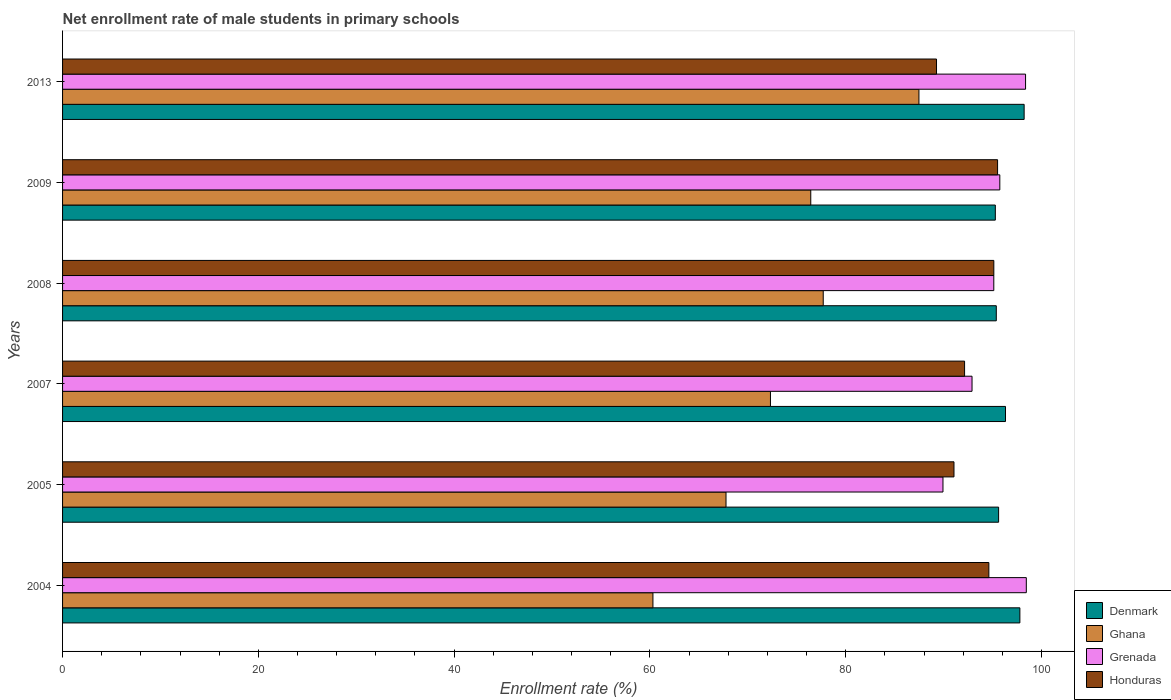How many groups of bars are there?
Make the answer very short. 6. Are the number of bars on each tick of the Y-axis equal?
Keep it short and to the point. Yes. How many bars are there on the 6th tick from the top?
Offer a terse response. 4. What is the label of the 1st group of bars from the top?
Offer a terse response. 2013. In how many cases, is the number of bars for a given year not equal to the number of legend labels?
Keep it short and to the point. 0. What is the net enrollment rate of male students in primary schools in Honduras in 2007?
Your answer should be very brief. 92.14. Across all years, what is the maximum net enrollment rate of male students in primary schools in Ghana?
Your answer should be very brief. 87.48. Across all years, what is the minimum net enrollment rate of male students in primary schools in Ghana?
Provide a short and direct response. 60.31. In which year was the net enrollment rate of male students in primary schools in Grenada maximum?
Offer a terse response. 2004. In which year was the net enrollment rate of male students in primary schools in Honduras minimum?
Your answer should be compact. 2013. What is the total net enrollment rate of male students in primary schools in Denmark in the graph?
Your response must be concise. 578.62. What is the difference between the net enrollment rate of male students in primary schools in Ghana in 2004 and that in 2005?
Offer a terse response. -7.46. What is the difference between the net enrollment rate of male students in primary schools in Denmark in 2005 and the net enrollment rate of male students in primary schools in Honduras in 2013?
Give a very brief answer. 6.34. What is the average net enrollment rate of male students in primary schools in Grenada per year?
Provide a short and direct response. 95.09. In the year 2008, what is the difference between the net enrollment rate of male students in primary schools in Grenada and net enrollment rate of male students in primary schools in Ghana?
Your answer should be very brief. 17.42. In how many years, is the net enrollment rate of male students in primary schools in Ghana greater than 88 %?
Keep it short and to the point. 0. What is the ratio of the net enrollment rate of male students in primary schools in Honduras in 2009 to that in 2013?
Ensure brevity in your answer.  1.07. Is the net enrollment rate of male students in primary schools in Grenada in 2005 less than that in 2013?
Ensure brevity in your answer.  Yes. What is the difference between the highest and the second highest net enrollment rate of male students in primary schools in Grenada?
Offer a very short reply. 0.08. What is the difference between the highest and the lowest net enrollment rate of male students in primary schools in Ghana?
Offer a very short reply. 27.17. Is the sum of the net enrollment rate of male students in primary schools in Grenada in 2005 and 2013 greater than the maximum net enrollment rate of male students in primary schools in Denmark across all years?
Your answer should be very brief. Yes. Is it the case that in every year, the sum of the net enrollment rate of male students in primary schools in Denmark and net enrollment rate of male students in primary schools in Grenada is greater than the sum of net enrollment rate of male students in primary schools in Ghana and net enrollment rate of male students in primary schools in Honduras?
Give a very brief answer. Yes. What does the 4th bar from the top in 2005 represents?
Make the answer very short. Denmark. What does the 3rd bar from the bottom in 2009 represents?
Ensure brevity in your answer.  Grenada. Is it the case that in every year, the sum of the net enrollment rate of male students in primary schools in Denmark and net enrollment rate of male students in primary schools in Honduras is greater than the net enrollment rate of male students in primary schools in Ghana?
Your response must be concise. Yes. What is the difference between two consecutive major ticks on the X-axis?
Ensure brevity in your answer.  20. Are the values on the major ticks of X-axis written in scientific E-notation?
Ensure brevity in your answer.  No. Does the graph contain any zero values?
Provide a short and direct response. No. How many legend labels are there?
Your answer should be very brief. 4. What is the title of the graph?
Provide a short and direct response. Net enrollment rate of male students in primary schools. Does "Madagascar" appear as one of the legend labels in the graph?
Your answer should be very brief. No. What is the label or title of the X-axis?
Keep it short and to the point. Enrollment rate (%). What is the label or title of the Y-axis?
Give a very brief answer. Years. What is the Enrollment rate (%) in Denmark in 2004?
Offer a terse response. 97.79. What is the Enrollment rate (%) in Ghana in 2004?
Offer a terse response. 60.31. What is the Enrollment rate (%) in Grenada in 2004?
Offer a terse response. 98.45. What is the Enrollment rate (%) of Honduras in 2004?
Offer a terse response. 94.62. What is the Enrollment rate (%) of Denmark in 2005?
Provide a short and direct response. 95.62. What is the Enrollment rate (%) in Ghana in 2005?
Make the answer very short. 67.77. What is the Enrollment rate (%) in Grenada in 2005?
Give a very brief answer. 89.93. What is the Enrollment rate (%) in Honduras in 2005?
Offer a very short reply. 91.06. What is the Enrollment rate (%) in Denmark in 2007?
Offer a very short reply. 96.32. What is the Enrollment rate (%) in Ghana in 2007?
Your answer should be very brief. 72.31. What is the Enrollment rate (%) of Grenada in 2007?
Your answer should be compact. 92.9. What is the Enrollment rate (%) in Honduras in 2007?
Your answer should be very brief. 92.14. What is the Enrollment rate (%) in Denmark in 2008?
Make the answer very short. 95.38. What is the Enrollment rate (%) of Ghana in 2008?
Keep it short and to the point. 77.7. What is the Enrollment rate (%) in Grenada in 2008?
Provide a succinct answer. 95.13. What is the Enrollment rate (%) of Honduras in 2008?
Keep it short and to the point. 95.13. What is the Enrollment rate (%) in Denmark in 2009?
Offer a terse response. 95.28. What is the Enrollment rate (%) of Ghana in 2009?
Offer a very short reply. 76.43. What is the Enrollment rate (%) in Grenada in 2009?
Ensure brevity in your answer.  95.74. What is the Enrollment rate (%) of Honduras in 2009?
Offer a very short reply. 95.51. What is the Enrollment rate (%) of Denmark in 2013?
Your answer should be very brief. 98.23. What is the Enrollment rate (%) of Ghana in 2013?
Offer a very short reply. 87.48. What is the Enrollment rate (%) in Grenada in 2013?
Your response must be concise. 98.37. What is the Enrollment rate (%) of Honduras in 2013?
Offer a very short reply. 89.28. Across all years, what is the maximum Enrollment rate (%) in Denmark?
Your answer should be compact. 98.23. Across all years, what is the maximum Enrollment rate (%) of Ghana?
Make the answer very short. 87.48. Across all years, what is the maximum Enrollment rate (%) of Grenada?
Offer a terse response. 98.45. Across all years, what is the maximum Enrollment rate (%) in Honduras?
Your answer should be compact. 95.51. Across all years, what is the minimum Enrollment rate (%) of Denmark?
Provide a short and direct response. 95.28. Across all years, what is the minimum Enrollment rate (%) of Ghana?
Ensure brevity in your answer.  60.31. Across all years, what is the minimum Enrollment rate (%) of Grenada?
Keep it short and to the point. 89.93. Across all years, what is the minimum Enrollment rate (%) of Honduras?
Ensure brevity in your answer.  89.28. What is the total Enrollment rate (%) in Denmark in the graph?
Your answer should be very brief. 578.62. What is the total Enrollment rate (%) of Ghana in the graph?
Give a very brief answer. 442. What is the total Enrollment rate (%) in Grenada in the graph?
Give a very brief answer. 570.52. What is the total Enrollment rate (%) in Honduras in the graph?
Offer a very short reply. 557.74. What is the difference between the Enrollment rate (%) in Denmark in 2004 and that in 2005?
Your response must be concise. 2.17. What is the difference between the Enrollment rate (%) of Ghana in 2004 and that in 2005?
Your answer should be very brief. -7.46. What is the difference between the Enrollment rate (%) of Grenada in 2004 and that in 2005?
Offer a very short reply. 8.51. What is the difference between the Enrollment rate (%) of Honduras in 2004 and that in 2005?
Your answer should be very brief. 3.56. What is the difference between the Enrollment rate (%) in Denmark in 2004 and that in 2007?
Keep it short and to the point. 1.47. What is the difference between the Enrollment rate (%) of Ghana in 2004 and that in 2007?
Make the answer very short. -12. What is the difference between the Enrollment rate (%) in Grenada in 2004 and that in 2007?
Give a very brief answer. 5.54. What is the difference between the Enrollment rate (%) in Honduras in 2004 and that in 2007?
Your answer should be compact. 2.48. What is the difference between the Enrollment rate (%) of Denmark in 2004 and that in 2008?
Make the answer very short. 2.41. What is the difference between the Enrollment rate (%) in Ghana in 2004 and that in 2008?
Make the answer very short. -17.4. What is the difference between the Enrollment rate (%) in Grenada in 2004 and that in 2008?
Your response must be concise. 3.32. What is the difference between the Enrollment rate (%) in Honduras in 2004 and that in 2008?
Provide a succinct answer. -0.51. What is the difference between the Enrollment rate (%) of Denmark in 2004 and that in 2009?
Offer a very short reply. 2.51. What is the difference between the Enrollment rate (%) in Ghana in 2004 and that in 2009?
Give a very brief answer. -16.12. What is the difference between the Enrollment rate (%) in Grenada in 2004 and that in 2009?
Provide a short and direct response. 2.71. What is the difference between the Enrollment rate (%) in Honduras in 2004 and that in 2009?
Keep it short and to the point. -0.89. What is the difference between the Enrollment rate (%) in Denmark in 2004 and that in 2013?
Ensure brevity in your answer.  -0.44. What is the difference between the Enrollment rate (%) of Ghana in 2004 and that in 2013?
Offer a very short reply. -27.17. What is the difference between the Enrollment rate (%) in Grenada in 2004 and that in 2013?
Offer a very short reply. 0.08. What is the difference between the Enrollment rate (%) in Honduras in 2004 and that in 2013?
Your response must be concise. 5.35. What is the difference between the Enrollment rate (%) in Denmark in 2005 and that in 2007?
Provide a short and direct response. -0.7. What is the difference between the Enrollment rate (%) of Ghana in 2005 and that in 2007?
Offer a very short reply. -4.54. What is the difference between the Enrollment rate (%) of Grenada in 2005 and that in 2007?
Your response must be concise. -2.97. What is the difference between the Enrollment rate (%) in Honduras in 2005 and that in 2007?
Your answer should be very brief. -1.08. What is the difference between the Enrollment rate (%) in Denmark in 2005 and that in 2008?
Make the answer very short. 0.24. What is the difference between the Enrollment rate (%) of Ghana in 2005 and that in 2008?
Your response must be concise. -9.93. What is the difference between the Enrollment rate (%) in Grenada in 2005 and that in 2008?
Offer a very short reply. -5.19. What is the difference between the Enrollment rate (%) of Honduras in 2005 and that in 2008?
Provide a succinct answer. -4.07. What is the difference between the Enrollment rate (%) in Denmark in 2005 and that in 2009?
Your response must be concise. 0.33. What is the difference between the Enrollment rate (%) in Ghana in 2005 and that in 2009?
Your answer should be compact. -8.66. What is the difference between the Enrollment rate (%) of Grenada in 2005 and that in 2009?
Provide a succinct answer. -5.81. What is the difference between the Enrollment rate (%) of Honduras in 2005 and that in 2009?
Your answer should be very brief. -4.45. What is the difference between the Enrollment rate (%) in Denmark in 2005 and that in 2013?
Offer a terse response. -2.61. What is the difference between the Enrollment rate (%) of Ghana in 2005 and that in 2013?
Provide a short and direct response. -19.71. What is the difference between the Enrollment rate (%) in Grenada in 2005 and that in 2013?
Offer a very short reply. -8.44. What is the difference between the Enrollment rate (%) in Honduras in 2005 and that in 2013?
Keep it short and to the point. 1.78. What is the difference between the Enrollment rate (%) in Denmark in 2007 and that in 2008?
Your answer should be very brief. 0.94. What is the difference between the Enrollment rate (%) of Ghana in 2007 and that in 2008?
Offer a very short reply. -5.39. What is the difference between the Enrollment rate (%) of Grenada in 2007 and that in 2008?
Give a very brief answer. -2.22. What is the difference between the Enrollment rate (%) in Honduras in 2007 and that in 2008?
Provide a short and direct response. -2.99. What is the difference between the Enrollment rate (%) of Denmark in 2007 and that in 2009?
Make the answer very short. 1.04. What is the difference between the Enrollment rate (%) in Ghana in 2007 and that in 2009?
Keep it short and to the point. -4.12. What is the difference between the Enrollment rate (%) in Grenada in 2007 and that in 2009?
Make the answer very short. -2.84. What is the difference between the Enrollment rate (%) in Honduras in 2007 and that in 2009?
Your response must be concise. -3.37. What is the difference between the Enrollment rate (%) in Denmark in 2007 and that in 2013?
Keep it short and to the point. -1.9. What is the difference between the Enrollment rate (%) in Ghana in 2007 and that in 2013?
Your response must be concise. -15.17. What is the difference between the Enrollment rate (%) in Grenada in 2007 and that in 2013?
Provide a short and direct response. -5.47. What is the difference between the Enrollment rate (%) of Honduras in 2007 and that in 2013?
Provide a short and direct response. 2.87. What is the difference between the Enrollment rate (%) of Denmark in 2008 and that in 2009?
Your answer should be compact. 0.1. What is the difference between the Enrollment rate (%) in Ghana in 2008 and that in 2009?
Make the answer very short. 1.27. What is the difference between the Enrollment rate (%) in Grenada in 2008 and that in 2009?
Your answer should be very brief. -0.62. What is the difference between the Enrollment rate (%) of Honduras in 2008 and that in 2009?
Offer a very short reply. -0.38. What is the difference between the Enrollment rate (%) of Denmark in 2008 and that in 2013?
Make the answer very short. -2.84. What is the difference between the Enrollment rate (%) in Ghana in 2008 and that in 2013?
Provide a succinct answer. -9.78. What is the difference between the Enrollment rate (%) in Grenada in 2008 and that in 2013?
Make the answer very short. -3.24. What is the difference between the Enrollment rate (%) of Honduras in 2008 and that in 2013?
Make the answer very short. 5.85. What is the difference between the Enrollment rate (%) in Denmark in 2009 and that in 2013?
Give a very brief answer. -2.94. What is the difference between the Enrollment rate (%) of Ghana in 2009 and that in 2013?
Your answer should be compact. -11.05. What is the difference between the Enrollment rate (%) in Grenada in 2009 and that in 2013?
Your response must be concise. -2.63. What is the difference between the Enrollment rate (%) of Honduras in 2009 and that in 2013?
Give a very brief answer. 6.24. What is the difference between the Enrollment rate (%) in Denmark in 2004 and the Enrollment rate (%) in Ghana in 2005?
Ensure brevity in your answer.  30.02. What is the difference between the Enrollment rate (%) of Denmark in 2004 and the Enrollment rate (%) of Grenada in 2005?
Provide a short and direct response. 7.86. What is the difference between the Enrollment rate (%) of Denmark in 2004 and the Enrollment rate (%) of Honduras in 2005?
Ensure brevity in your answer.  6.73. What is the difference between the Enrollment rate (%) of Ghana in 2004 and the Enrollment rate (%) of Grenada in 2005?
Your answer should be very brief. -29.63. What is the difference between the Enrollment rate (%) in Ghana in 2004 and the Enrollment rate (%) in Honduras in 2005?
Give a very brief answer. -30.75. What is the difference between the Enrollment rate (%) of Grenada in 2004 and the Enrollment rate (%) of Honduras in 2005?
Ensure brevity in your answer.  7.39. What is the difference between the Enrollment rate (%) of Denmark in 2004 and the Enrollment rate (%) of Ghana in 2007?
Provide a succinct answer. 25.48. What is the difference between the Enrollment rate (%) of Denmark in 2004 and the Enrollment rate (%) of Grenada in 2007?
Offer a very short reply. 4.89. What is the difference between the Enrollment rate (%) of Denmark in 2004 and the Enrollment rate (%) of Honduras in 2007?
Offer a terse response. 5.65. What is the difference between the Enrollment rate (%) in Ghana in 2004 and the Enrollment rate (%) in Grenada in 2007?
Provide a short and direct response. -32.6. What is the difference between the Enrollment rate (%) of Ghana in 2004 and the Enrollment rate (%) of Honduras in 2007?
Provide a short and direct response. -31.83. What is the difference between the Enrollment rate (%) of Grenada in 2004 and the Enrollment rate (%) of Honduras in 2007?
Make the answer very short. 6.31. What is the difference between the Enrollment rate (%) in Denmark in 2004 and the Enrollment rate (%) in Ghana in 2008?
Provide a succinct answer. 20.09. What is the difference between the Enrollment rate (%) in Denmark in 2004 and the Enrollment rate (%) in Grenada in 2008?
Give a very brief answer. 2.66. What is the difference between the Enrollment rate (%) in Denmark in 2004 and the Enrollment rate (%) in Honduras in 2008?
Provide a succinct answer. 2.66. What is the difference between the Enrollment rate (%) of Ghana in 2004 and the Enrollment rate (%) of Grenada in 2008?
Your answer should be compact. -34.82. What is the difference between the Enrollment rate (%) in Ghana in 2004 and the Enrollment rate (%) in Honduras in 2008?
Your answer should be compact. -34.82. What is the difference between the Enrollment rate (%) of Grenada in 2004 and the Enrollment rate (%) of Honduras in 2008?
Provide a short and direct response. 3.32. What is the difference between the Enrollment rate (%) in Denmark in 2004 and the Enrollment rate (%) in Ghana in 2009?
Your response must be concise. 21.36. What is the difference between the Enrollment rate (%) of Denmark in 2004 and the Enrollment rate (%) of Grenada in 2009?
Offer a terse response. 2.05. What is the difference between the Enrollment rate (%) in Denmark in 2004 and the Enrollment rate (%) in Honduras in 2009?
Your response must be concise. 2.28. What is the difference between the Enrollment rate (%) of Ghana in 2004 and the Enrollment rate (%) of Grenada in 2009?
Make the answer very short. -35.43. What is the difference between the Enrollment rate (%) in Ghana in 2004 and the Enrollment rate (%) in Honduras in 2009?
Give a very brief answer. -35.2. What is the difference between the Enrollment rate (%) of Grenada in 2004 and the Enrollment rate (%) of Honduras in 2009?
Keep it short and to the point. 2.94. What is the difference between the Enrollment rate (%) in Denmark in 2004 and the Enrollment rate (%) in Ghana in 2013?
Give a very brief answer. 10.31. What is the difference between the Enrollment rate (%) in Denmark in 2004 and the Enrollment rate (%) in Grenada in 2013?
Ensure brevity in your answer.  -0.58. What is the difference between the Enrollment rate (%) in Denmark in 2004 and the Enrollment rate (%) in Honduras in 2013?
Offer a very short reply. 8.51. What is the difference between the Enrollment rate (%) in Ghana in 2004 and the Enrollment rate (%) in Grenada in 2013?
Offer a terse response. -38.06. What is the difference between the Enrollment rate (%) in Ghana in 2004 and the Enrollment rate (%) in Honduras in 2013?
Give a very brief answer. -28.97. What is the difference between the Enrollment rate (%) in Grenada in 2004 and the Enrollment rate (%) in Honduras in 2013?
Your response must be concise. 9.17. What is the difference between the Enrollment rate (%) of Denmark in 2005 and the Enrollment rate (%) of Ghana in 2007?
Your answer should be compact. 23.31. What is the difference between the Enrollment rate (%) in Denmark in 2005 and the Enrollment rate (%) in Grenada in 2007?
Ensure brevity in your answer.  2.71. What is the difference between the Enrollment rate (%) of Denmark in 2005 and the Enrollment rate (%) of Honduras in 2007?
Provide a short and direct response. 3.48. What is the difference between the Enrollment rate (%) of Ghana in 2005 and the Enrollment rate (%) of Grenada in 2007?
Offer a terse response. -25.13. What is the difference between the Enrollment rate (%) in Ghana in 2005 and the Enrollment rate (%) in Honduras in 2007?
Keep it short and to the point. -24.37. What is the difference between the Enrollment rate (%) in Grenada in 2005 and the Enrollment rate (%) in Honduras in 2007?
Ensure brevity in your answer.  -2.21. What is the difference between the Enrollment rate (%) in Denmark in 2005 and the Enrollment rate (%) in Ghana in 2008?
Give a very brief answer. 17.91. What is the difference between the Enrollment rate (%) of Denmark in 2005 and the Enrollment rate (%) of Grenada in 2008?
Your response must be concise. 0.49. What is the difference between the Enrollment rate (%) in Denmark in 2005 and the Enrollment rate (%) in Honduras in 2008?
Your answer should be compact. 0.49. What is the difference between the Enrollment rate (%) of Ghana in 2005 and the Enrollment rate (%) of Grenada in 2008?
Provide a short and direct response. -27.35. What is the difference between the Enrollment rate (%) in Ghana in 2005 and the Enrollment rate (%) in Honduras in 2008?
Your answer should be compact. -27.36. What is the difference between the Enrollment rate (%) of Grenada in 2005 and the Enrollment rate (%) of Honduras in 2008?
Ensure brevity in your answer.  -5.2. What is the difference between the Enrollment rate (%) in Denmark in 2005 and the Enrollment rate (%) in Ghana in 2009?
Make the answer very short. 19.19. What is the difference between the Enrollment rate (%) in Denmark in 2005 and the Enrollment rate (%) in Grenada in 2009?
Keep it short and to the point. -0.12. What is the difference between the Enrollment rate (%) of Denmark in 2005 and the Enrollment rate (%) of Honduras in 2009?
Provide a short and direct response. 0.11. What is the difference between the Enrollment rate (%) in Ghana in 2005 and the Enrollment rate (%) in Grenada in 2009?
Provide a short and direct response. -27.97. What is the difference between the Enrollment rate (%) of Ghana in 2005 and the Enrollment rate (%) of Honduras in 2009?
Your response must be concise. -27.74. What is the difference between the Enrollment rate (%) in Grenada in 2005 and the Enrollment rate (%) in Honduras in 2009?
Offer a very short reply. -5.58. What is the difference between the Enrollment rate (%) in Denmark in 2005 and the Enrollment rate (%) in Ghana in 2013?
Your answer should be very brief. 8.14. What is the difference between the Enrollment rate (%) in Denmark in 2005 and the Enrollment rate (%) in Grenada in 2013?
Provide a short and direct response. -2.75. What is the difference between the Enrollment rate (%) of Denmark in 2005 and the Enrollment rate (%) of Honduras in 2013?
Provide a succinct answer. 6.34. What is the difference between the Enrollment rate (%) of Ghana in 2005 and the Enrollment rate (%) of Grenada in 2013?
Offer a very short reply. -30.6. What is the difference between the Enrollment rate (%) of Ghana in 2005 and the Enrollment rate (%) of Honduras in 2013?
Give a very brief answer. -21.5. What is the difference between the Enrollment rate (%) of Grenada in 2005 and the Enrollment rate (%) of Honduras in 2013?
Offer a very short reply. 0.66. What is the difference between the Enrollment rate (%) of Denmark in 2007 and the Enrollment rate (%) of Ghana in 2008?
Your answer should be compact. 18.62. What is the difference between the Enrollment rate (%) of Denmark in 2007 and the Enrollment rate (%) of Grenada in 2008?
Ensure brevity in your answer.  1.2. What is the difference between the Enrollment rate (%) of Denmark in 2007 and the Enrollment rate (%) of Honduras in 2008?
Provide a short and direct response. 1.19. What is the difference between the Enrollment rate (%) of Ghana in 2007 and the Enrollment rate (%) of Grenada in 2008?
Keep it short and to the point. -22.81. What is the difference between the Enrollment rate (%) in Ghana in 2007 and the Enrollment rate (%) in Honduras in 2008?
Your answer should be compact. -22.82. What is the difference between the Enrollment rate (%) in Grenada in 2007 and the Enrollment rate (%) in Honduras in 2008?
Your answer should be very brief. -2.23. What is the difference between the Enrollment rate (%) in Denmark in 2007 and the Enrollment rate (%) in Ghana in 2009?
Your answer should be very brief. 19.89. What is the difference between the Enrollment rate (%) of Denmark in 2007 and the Enrollment rate (%) of Grenada in 2009?
Give a very brief answer. 0.58. What is the difference between the Enrollment rate (%) in Denmark in 2007 and the Enrollment rate (%) in Honduras in 2009?
Offer a terse response. 0.81. What is the difference between the Enrollment rate (%) in Ghana in 2007 and the Enrollment rate (%) in Grenada in 2009?
Offer a very short reply. -23.43. What is the difference between the Enrollment rate (%) in Ghana in 2007 and the Enrollment rate (%) in Honduras in 2009?
Your answer should be very brief. -23.2. What is the difference between the Enrollment rate (%) in Grenada in 2007 and the Enrollment rate (%) in Honduras in 2009?
Offer a terse response. -2.61. What is the difference between the Enrollment rate (%) in Denmark in 2007 and the Enrollment rate (%) in Ghana in 2013?
Offer a terse response. 8.84. What is the difference between the Enrollment rate (%) in Denmark in 2007 and the Enrollment rate (%) in Grenada in 2013?
Keep it short and to the point. -2.05. What is the difference between the Enrollment rate (%) in Denmark in 2007 and the Enrollment rate (%) in Honduras in 2013?
Your answer should be compact. 7.05. What is the difference between the Enrollment rate (%) in Ghana in 2007 and the Enrollment rate (%) in Grenada in 2013?
Your answer should be compact. -26.06. What is the difference between the Enrollment rate (%) in Ghana in 2007 and the Enrollment rate (%) in Honduras in 2013?
Offer a very short reply. -16.96. What is the difference between the Enrollment rate (%) in Grenada in 2007 and the Enrollment rate (%) in Honduras in 2013?
Offer a terse response. 3.63. What is the difference between the Enrollment rate (%) in Denmark in 2008 and the Enrollment rate (%) in Ghana in 2009?
Provide a short and direct response. 18.95. What is the difference between the Enrollment rate (%) of Denmark in 2008 and the Enrollment rate (%) of Grenada in 2009?
Provide a succinct answer. -0.36. What is the difference between the Enrollment rate (%) of Denmark in 2008 and the Enrollment rate (%) of Honduras in 2009?
Your response must be concise. -0.13. What is the difference between the Enrollment rate (%) of Ghana in 2008 and the Enrollment rate (%) of Grenada in 2009?
Your response must be concise. -18.04. What is the difference between the Enrollment rate (%) of Ghana in 2008 and the Enrollment rate (%) of Honduras in 2009?
Your answer should be compact. -17.81. What is the difference between the Enrollment rate (%) of Grenada in 2008 and the Enrollment rate (%) of Honduras in 2009?
Provide a short and direct response. -0.39. What is the difference between the Enrollment rate (%) of Denmark in 2008 and the Enrollment rate (%) of Ghana in 2013?
Offer a very short reply. 7.9. What is the difference between the Enrollment rate (%) in Denmark in 2008 and the Enrollment rate (%) in Grenada in 2013?
Ensure brevity in your answer.  -2.99. What is the difference between the Enrollment rate (%) in Denmark in 2008 and the Enrollment rate (%) in Honduras in 2013?
Ensure brevity in your answer.  6.11. What is the difference between the Enrollment rate (%) in Ghana in 2008 and the Enrollment rate (%) in Grenada in 2013?
Make the answer very short. -20.67. What is the difference between the Enrollment rate (%) in Ghana in 2008 and the Enrollment rate (%) in Honduras in 2013?
Your answer should be compact. -11.57. What is the difference between the Enrollment rate (%) of Grenada in 2008 and the Enrollment rate (%) of Honduras in 2013?
Offer a terse response. 5.85. What is the difference between the Enrollment rate (%) of Denmark in 2009 and the Enrollment rate (%) of Ghana in 2013?
Your answer should be compact. 7.8. What is the difference between the Enrollment rate (%) of Denmark in 2009 and the Enrollment rate (%) of Grenada in 2013?
Keep it short and to the point. -3.09. What is the difference between the Enrollment rate (%) in Denmark in 2009 and the Enrollment rate (%) in Honduras in 2013?
Offer a terse response. 6.01. What is the difference between the Enrollment rate (%) of Ghana in 2009 and the Enrollment rate (%) of Grenada in 2013?
Give a very brief answer. -21.94. What is the difference between the Enrollment rate (%) in Ghana in 2009 and the Enrollment rate (%) in Honduras in 2013?
Keep it short and to the point. -12.85. What is the difference between the Enrollment rate (%) in Grenada in 2009 and the Enrollment rate (%) in Honduras in 2013?
Your response must be concise. 6.47. What is the average Enrollment rate (%) of Denmark per year?
Provide a short and direct response. 96.44. What is the average Enrollment rate (%) in Ghana per year?
Provide a short and direct response. 73.67. What is the average Enrollment rate (%) in Grenada per year?
Offer a terse response. 95.09. What is the average Enrollment rate (%) of Honduras per year?
Provide a succinct answer. 92.96. In the year 2004, what is the difference between the Enrollment rate (%) in Denmark and Enrollment rate (%) in Ghana?
Provide a short and direct response. 37.48. In the year 2004, what is the difference between the Enrollment rate (%) in Denmark and Enrollment rate (%) in Grenada?
Offer a terse response. -0.66. In the year 2004, what is the difference between the Enrollment rate (%) in Denmark and Enrollment rate (%) in Honduras?
Your response must be concise. 3.17. In the year 2004, what is the difference between the Enrollment rate (%) in Ghana and Enrollment rate (%) in Grenada?
Your answer should be very brief. -38.14. In the year 2004, what is the difference between the Enrollment rate (%) in Ghana and Enrollment rate (%) in Honduras?
Offer a terse response. -34.31. In the year 2004, what is the difference between the Enrollment rate (%) of Grenada and Enrollment rate (%) of Honduras?
Make the answer very short. 3.82. In the year 2005, what is the difference between the Enrollment rate (%) of Denmark and Enrollment rate (%) of Ghana?
Your response must be concise. 27.84. In the year 2005, what is the difference between the Enrollment rate (%) in Denmark and Enrollment rate (%) in Grenada?
Provide a short and direct response. 5.68. In the year 2005, what is the difference between the Enrollment rate (%) of Denmark and Enrollment rate (%) of Honduras?
Your answer should be very brief. 4.56. In the year 2005, what is the difference between the Enrollment rate (%) of Ghana and Enrollment rate (%) of Grenada?
Your answer should be very brief. -22.16. In the year 2005, what is the difference between the Enrollment rate (%) in Ghana and Enrollment rate (%) in Honduras?
Keep it short and to the point. -23.29. In the year 2005, what is the difference between the Enrollment rate (%) of Grenada and Enrollment rate (%) of Honduras?
Your response must be concise. -1.13. In the year 2007, what is the difference between the Enrollment rate (%) of Denmark and Enrollment rate (%) of Ghana?
Make the answer very short. 24.01. In the year 2007, what is the difference between the Enrollment rate (%) of Denmark and Enrollment rate (%) of Grenada?
Provide a short and direct response. 3.42. In the year 2007, what is the difference between the Enrollment rate (%) of Denmark and Enrollment rate (%) of Honduras?
Your answer should be compact. 4.18. In the year 2007, what is the difference between the Enrollment rate (%) of Ghana and Enrollment rate (%) of Grenada?
Your answer should be compact. -20.59. In the year 2007, what is the difference between the Enrollment rate (%) in Ghana and Enrollment rate (%) in Honduras?
Give a very brief answer. -19.83. In the year 2007, what is the difference between the Enrollment rate (%) in Grenada and Enrollment rate (%) in Honduras?
Offer a very short reply. 0.76. In the year 2008, what is the difference between the Enrollment rate (%) in Denmark and Enrollment rate (%) in Ghana?
Keep it short and to the point. 17.68. In the year 2008, what is the difference between the Enrollment rate (%) in Denmark and Enrollment rate (%) in Grenada?
Offer a terse response. 0.26. In the year 2008, what is the difference between the Enrollment rate (%) in Denmark and Enrollment rate (%) in Honduras?
Offer a terse response. 0.25. In the year 2008, what is the difference between the Enrollment rate (%) in Ghana and Enrollment rate (%) in Grenada?
Give a very brief answer. -17.42. In the year 2008, what is the difference between the Enrollment rate (%) in Ghana and Enrollment rate (%) in Honduras?
Provide a short and direct response. -17.43. In the year 2008, what is the difference between the Enrollment rate (%) in Grenada and Enrollment rate (%) in Honduras?
Your answer should be very brief. -0. In the year 2009, what is the difference between the Enrollment rate (%) of Denmark and Enrollment rate (%) of Ghana?
Your answer should be compact. 18.85. In the year 2009, what is the difference between the Enrollment rate (%) of Denmark and Enrollment rate (%) of Grenada?
Make the answer very short. -0.46. In the year 2009, what is the difference between the Enrollment rate (%) in Denmark and Enrollment rate (%) in Honduras?
Your answer should be very brief. -0.23. In the year 2009, what is the difference between the Enrollment rate (%) in Ghana and Enrollment rate (%) in Grenada?
Keep it short and to the point. -19.31. In the year 2009, what is the difference between the Enrollment rate (%) in Ghana and Enrollment rate (%) in Honduras?
Provide a succinct answer. -19.08. In the year 2009, what is the difference between the Enrollment rate (%) in Grenada and Enrollment rate (%) in Honduras?
Make the answer very short. 0.23. In the year 2013, what is the difference between the Enrollment rate (%) in Denmark and Enrollment rate (%) in Ghana?
Offer a very short reply. 10.75. In the year 2013, what is the difference between the Enrollment rate (%) in Denmark and Enrollment rate (%) in Grenada?
Give a very brief answer. -0.14. In the year 2013, what is the difference between the Enrollment rate (%) in Denmark and Enrollment rate (%) in Honduras?
Keep it short and to the point. 8.95. In the year 2013, what is the difference between the Enrollment rate (%) in Ghana and Enrollment rate (%) in Grenada?
Your answer should be compact. -10.89. In the year 2013, what is the difference between the Enrollment rate (%) of Ghana and Enrollment rate (%) of Honduras?
Offer a very short reply. -1.8. In the year 2013, what is the difference between the Enrollment rate (%) of Grenada and Enrollment rate (%) of Honduras?
Keep it short and to the point. 9.1. What is the ratio of the Enrollment rate (%) in Denmark in 2004 to that in 2005?
Provide a succinct answer. 1.02. What is the ratio of the Enrollment rate (%) of Ghana in 2004 to that in 2005?
Provide a short and direct response. 0.89. What is the ratio of the Enrollment rate (%) of Grenada in 2004 to that in 2005?
Offer a terse response. 1.09. What is the ratio of the Enrollment rate (%) of Honduras in 2004 to that in 2005?
Your response must be concise. 1.04. What is the ratio of the Enrollment rate (%) of Denmark in 2004 to that in 2007?
Your answer should be compact. 1.02. What is the ratio of the Enrollment rate (%) in Ghana in 2004 to that in 2007?
Your response must be concise. 0.83. What is the ratio of the Enrollment rate (%) in Grenada in 2004 to that in 2007?
Make the answer very short. 1.06. What is the ratio of the Enrollment rate (%) in Honduras in 2004 to that in 2007?
Offer a terse response. 1.03. What is the ratio of the Enrollment rate (%) of Denmark in 2004 to that in 2008?
Your answer should be very brief. 1.03. What is the ratio of the Enrollment rate (%) of Ghana in 2004 to that in 2008?
Your response must be concise. 0.78. What is the ratio of the Enrollment rate (%) of Grenada in 2004 to that in 2008?
Your answer should be very brief. 1.03. What is the ratio of the Enrollment rate (%) in Denmark in 2004 to that in 2009?
Your answer should be very brief. 1.03. What is the ratio of the Enrollment rate (%) of Ghana in 2004 to that in 2009?
Your answer should be compact. 0.79. What is the ratio of the Enrollment rate (%) in Grenada in 2004 to that in 2009?
Your response must be concise. 1.03. What is the ratio of the Enrollment rate (%) in Honduras in 2004 to that in 2009?
Your answer should be very brief. 0.99. What is the ratio of the Enrollment rate (%) in Ghana in 2004 to that in 2013?
Offer a very short reply. 0.69. What is the ratio of the Enrollment rate (%) of Grenada in 2004 to that in 2013?
Provide a short and direct response. 1. What is the ratio of the Enrollment rate (%) of Honduras in 2004 to that in 2013?
Make the answer very short. 1.06. What is the ratio of the Enrollment rate (%) of Denmark in 2005 to that in 2007?
Make the answer very short. 0.99. What is the ratio of the Enrollment rate (%) of Ghana in 2005 to that in 2007?
Ensure brevity in your answer.  0.94. What is the ratio of the Enrollment rate (%) in Honduras in 2005 to that in 2007?
Your response must be concise. 0.99. What is the ratio of the Enrollment rate (%) of Denmark in 2005 to that in 2008?
Make the answer very short. 1. What is the ratio of the Enrollment rate (%) of Ghana in 2005 to that in 2008?
Give a very brief answer. 0.87. What is the ratio of the Enrollment rate (%) in Grenada in 2005 to that in 2008?
Make the answer very short. 0.95. What is the ratio of the Enrollment rate (%) in Honduras in 2005 to that in 2008?
Keep it short and to the point. 0.96. What is the ratio of the Enrollment rate (%) of Ghana in 2005 to that in 2009?
Give a very brief answer. 0.89. What is the ratio of the Enrollment rate (%) in Grenada in 2005 to that in 2009?
Your answer should be compact. 0.94. What is the ratio of the Enrollment rate (%) in Honduras in 2005 to that in 2009?
Make the answer very short. 0.95. What is the ratio of the Enrollment rate (%) in Denmark in 2005 to that in 2013?
Offer a terse response. 0.97. What is the ratio of the Enrollment rate (%) of Ghana in 2005 to that in 2013?
Give a very brief answer. 0.77. What is the ratio of the Enrollment rate (%) in Grenada in 2005 to that in 2013?
Provide a succinct answer. 0.91. What is the ratio of the Enrollment rate (%) in Denmark in 2007 to that in 2008?
Make the answer very short. 1.01. What is the ratio of the Enrollment rate (%) in Ghana in 2007 to that in 2008?
Offer a terse response. 0.93. What is the ratio of the Enrollment rate (%) in Grenada in 2007 to that in 2008?
Offer a very short reply. 0.98. What is the ratio of the Enrollment rate (%) in Honduras in 2007 to that in 2008?
Keep it short and to the point. 0.97. What is the ratio of the Enrollment rate (%) of Denmark in 2007 to that in 2009?
Your answer should be compact. 1.01. What is the ratio of the Enrollment rate (%) in Ghana in 2007 to that in 2009?
Your answer should be very brief. 0.95. What is the ratio of the Enrollment rate (%) of Grenada in 2007 to that in 2009?
Provide a short and direct response. 0.97. What is the ratio of the Enrollment rate (%) of Honduras in 2007 to that in 2009?
Keep it short and to the point. 0.96. What is the ratio of the Enrollment rate (%) in Denmark in 2007 to that in 2013?
Keep it short and to the point. 0.98. What is the ratio of the Enrollment rate (%) of Ghana in 2007 to that in 2013?
Your response must be concise. 0.83. What is the ratio of the Enrollment rate (%) in Honduras in 2007 to that in 2013?
Provide a succinct answer. 1.03. What is the ratio of the Enrollment rate (%) in Denmark in 2008 to that in 2009?
Provide a succinct answer. 1. What is the ratio of the Enrollment rate (%) in Ghana in 2008 to that in 2009?
Provide a short and direct response. 1.02. What is the ratio of the Enrollment rate (%) in Grenada in 2008 to that in 2009?
Keep it short and to the point. 0.99. What is the ratio of the Enrollment rate (%) in Denmark in 2008 to that in 2013?
Make the answer very short. 0.97. What is the ratio of the Enrollment rate (%) in Ghana in 2008 to that in 2013?
Your response must be concise. 0.89. What is the ratio of the Enrollment rate (%) of Grenada in 2008 to that in 2013?
Give a very brief answer. 0.97. What is the ratio of the Enrollment rate (%) in Honduras in 2008 to that in 2013?
Offer a terse response. 1.07. What is the ratio of the Enrollment rate (%) of Denmark in 2009 to that in 2013?
Offer a very short reply. 0.97. What is the ratio of the Enrollment rate (%) in Ghana in 2009 to that in 2013?
Offer a terse response. 0.87. What is the ratio of the Enrollment rate (%) in Grenada in 2009 to that in 2013?
Your response must be concise. 0.97. What is the ratio of the Enrollment rate (%) in Honduras in 2009 to that in 2013?
Your answer should be very brief. 1.07. What is the difference between the highest and the second highest Enrollment rate (%) in Denmark?
Your answer should be compact. 0.44. What is the difference between the highest and the second highest Enrollment rate (%) in Ghana?
Ensure brevity in your answer.  9.78. What is the difference between the highest and the second highest Enrollment rate (%) in Grenada?
Keep it short and to the point. 0.08. What is the difference between the highest and the second highest Enrollment rate (%) of Honduras?
Ensure brevity in your answer.  0.38. What is the difference between the highest and the lowest Enrollment rate (%) of Denmark?
Offer a very short reply. 2.94. What is the difference between the highest and the lowest Enrollment rate (%) of Ghana?
Provide a succinct answer. 27.17. What is the difference between the highest and the lowest Enrollment rate (%) of Grenada?
Provide a short and direct response. 8.51. What is the difference between the highest and the lowest Enrollment rate (%) in Honduras?
Give a very brief answer. 6.24. 